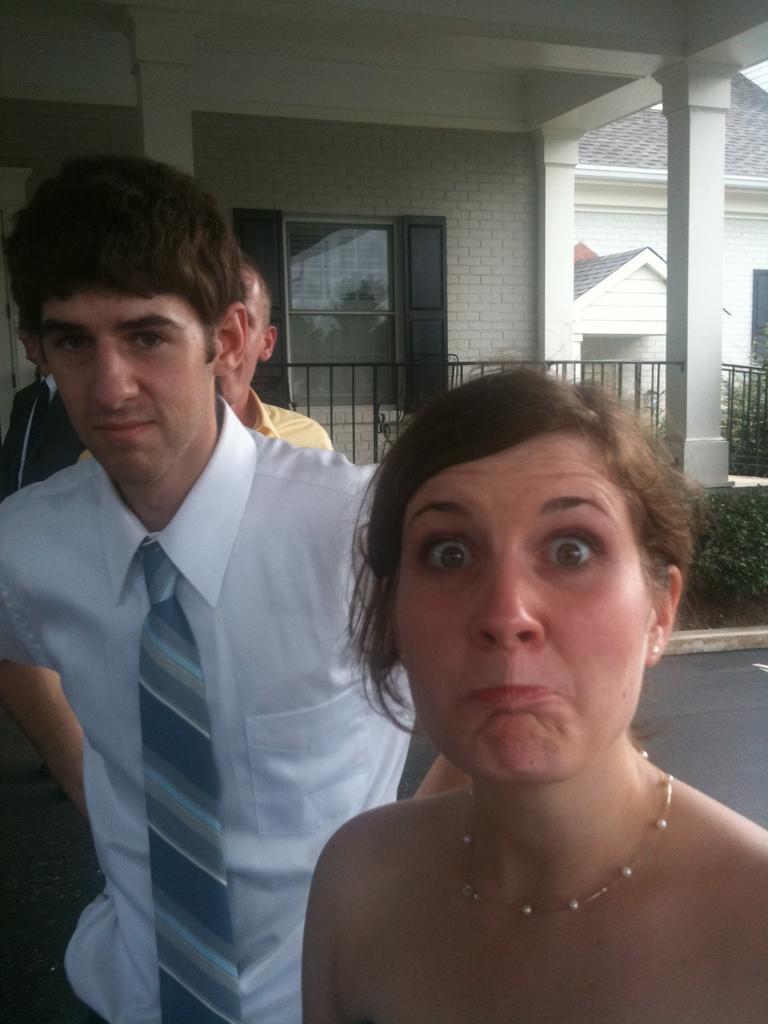Describe this image in one or two sentences. In the foreground of this image, on the right, there is a woman. On the left, there are men standing. In the background, there is a house, railing and few plants. 